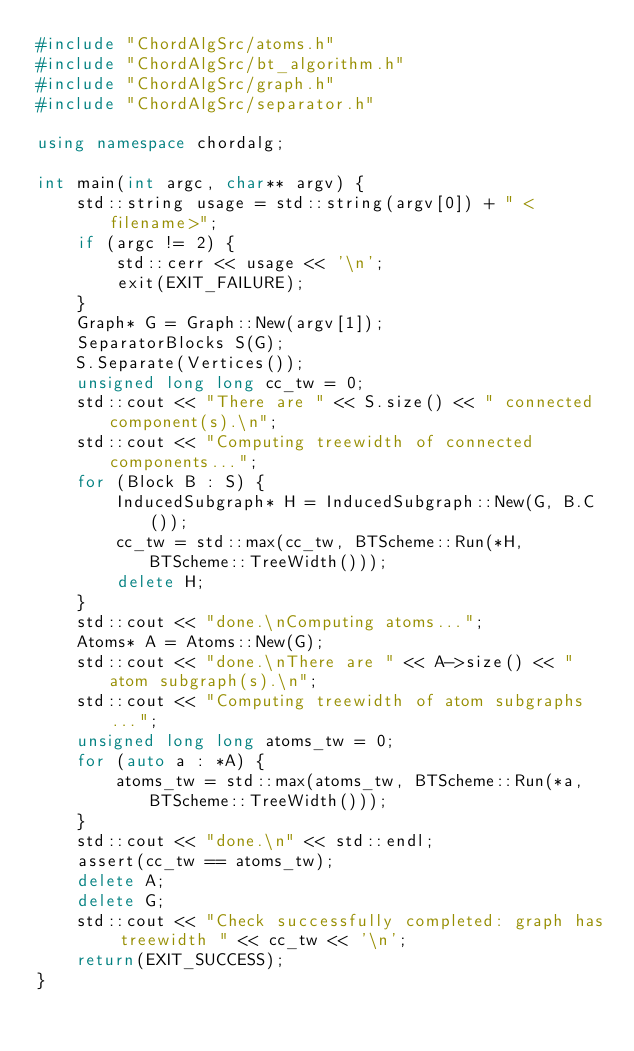Convert code to text. <code><loc_0><loc_0><loc_500><loc_500><_C++_>#include "ChordAlgSrc/atoms.h"
#include "ChordAlgSrc/bt_algorithm.h"
#include "ChordAlgSrc/graph.h"
#include "ChordAlgSrc/separator.h"

using namespace chordalg;

int main(int argc, char** argv) {
    std::string usage = std::string(argv[0]) + " <filename>";
    if (argc != 2) {
        std::cerr << usage << '\n';
        exit(EXIT_FAILURE);
    }
    Graph* G = Graph::New(argv[1]);
    SeparatorBlocks S(G);
    S.Separate(Vertices());
    unsigned long long cc_tw = 0;
    std::cout << "There are " << S.size() << " connected component(s).\n";
    std::cout << "Computing treewidth of connected components...";
    for (Block B : S) {
        InducedSubgraph* H = InducedSubgraph::New(G, B.C());
        cc_tw = std::max(cc_tw, BTScheme::Run(*H, BTScheme::TreeWidth()));
        delete H;
    }
    std::cout << "done.\nComputing atoms...";
    Atoms* A = Atoms::New(G);
    std::cout << "done.\nThere are " << A->size() << " atom subgraph(s).\n";
    std::cout << "Computing treewidth of atom subgraphs...";
    unsigned long long atoms_tw = 0;
    for (auto a : *A) {
        atoms_tw = std::max(atoms_tw, BTScheme::Run(*a, BTScheme::TreeWidth()));
    }
    std::cout << "done.\n" << std::endl;
    assert(cc_tw == atoms_tw);
    delete A;
    delete G;
    std::cout << "Check successfully completed: graph has treewidth " << cc_tw << '\n';
    return(EXIT_SUCCESS);
}
</code> 